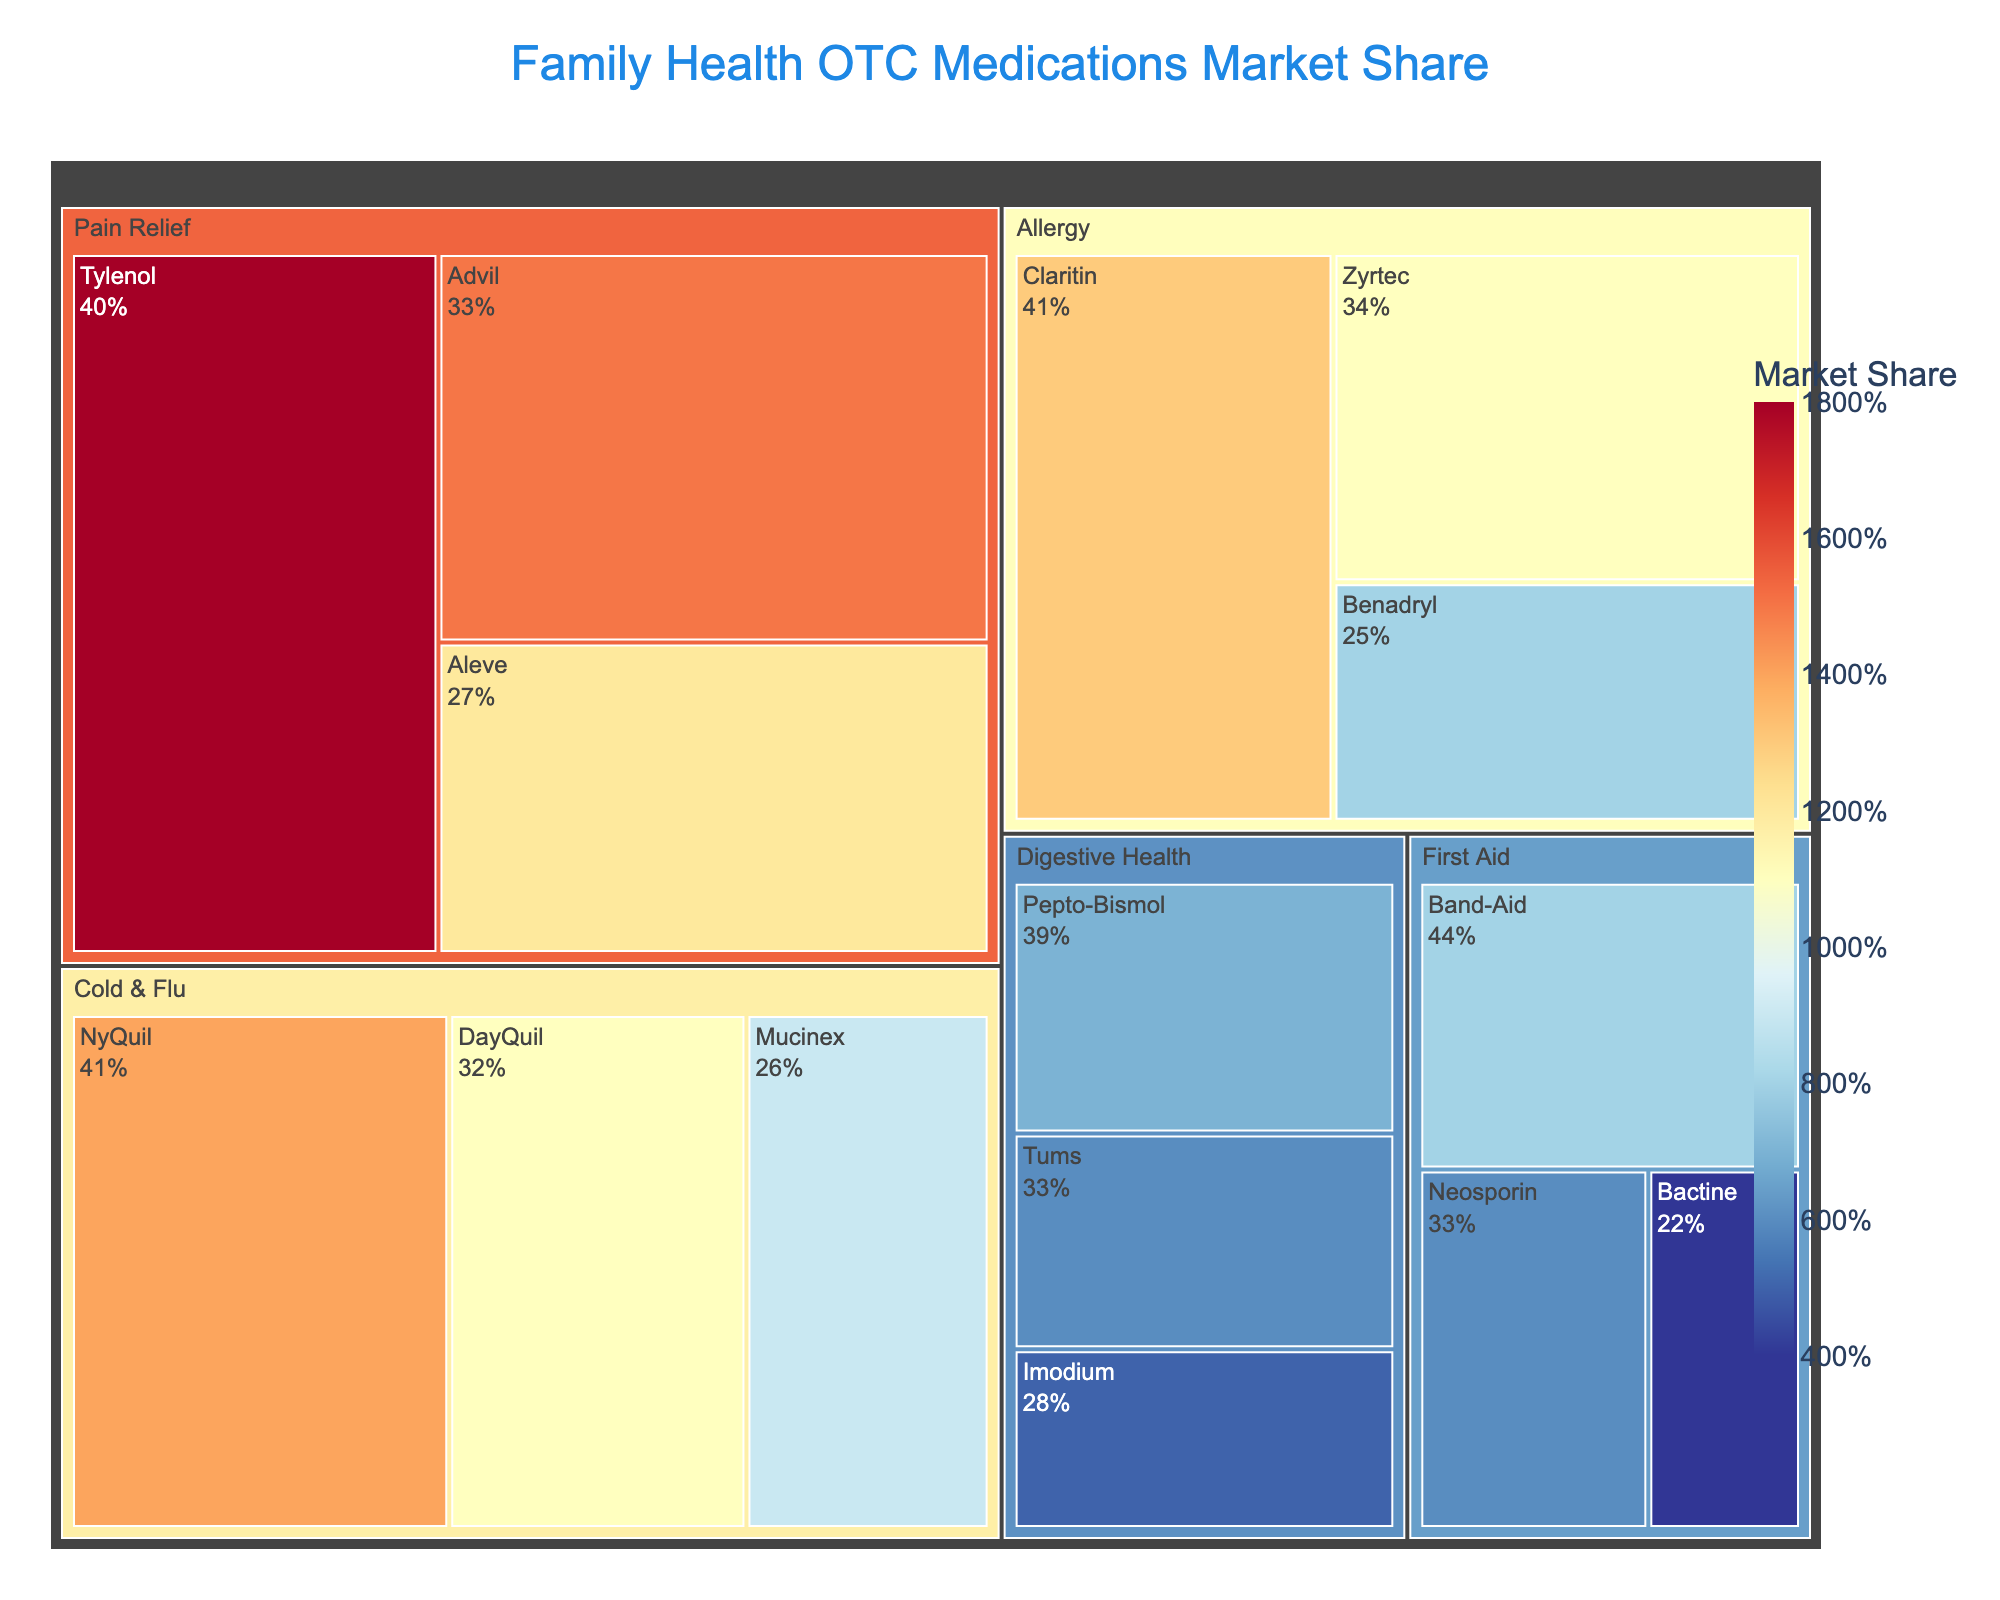What is the title of the figure? The title is typically displayed at the top of the figure. In this case, the title is "Family Health OTC Medications Market Share".
Answer: Family Health OTC Medications Market Share Which category has the highest market share overall? To determine this, look at the largest sections in the Treemap. Pain Relief has the largest in terms of combination of subcategories: Tylenol, Advil, and Aleve.
Answer: Pain Relief What are the specific market shares for Tylenol, Advil, and Aleve? Refer to the specific sections within the Pain Relief category. Tylenol has 18%, Advil has 15%, and Aleve has 12%.
Answer: Tylenol 18%, Advil 15%, Aleve 12% Which medication within the Allergy category has the highest market share? Within the Allergy category, compare the sizes of the subcategories. Claritin, with a market share of 13%, has the highest share.
Answer: Claritin What is the total market share for all Cold & Flu medications? Sum the market shares for NyQuil (14%), DayQuil (11%), and Mucinex (9%). 14% + 11% + 9% = 34%.
Answer: 34% Which has a higher market share: Benadryl or Mucinex? Compare the market shares for Benadryl (8%) and Mucinex (9%). Mucinex has a higher share.
Answer: Mucinex Amongst Digestive Health and First Aid categories, which has the smallest market share medication? Compare the smallest subcategory shares in Digestive Health (Imodium, 5%) and First Aid (Bactine, 4%). Bactine has the smallest share.
Answer: Bactine How does the market share of Claritin compare to DayQuil? Compare the market shares directly. Claritin has 13% while DayQuil has 11%. Claritin has a higher share.
Answer: Claritin What is the total market share of the First Aid category? Sum the market shares for Band-Aid (8%), Neosporin (6%), and Bactine (4%). 8% + 6% + 4% = 18%.
Answer: 18% What is more popular within the Digestive Health category: Pepto-Bismol or Tums? Compare the market share values. Pepto-Bismol has 7%, and Tums has 6%. Pepto-Bismol is more popular.
Answer: Pepto-Bismol 